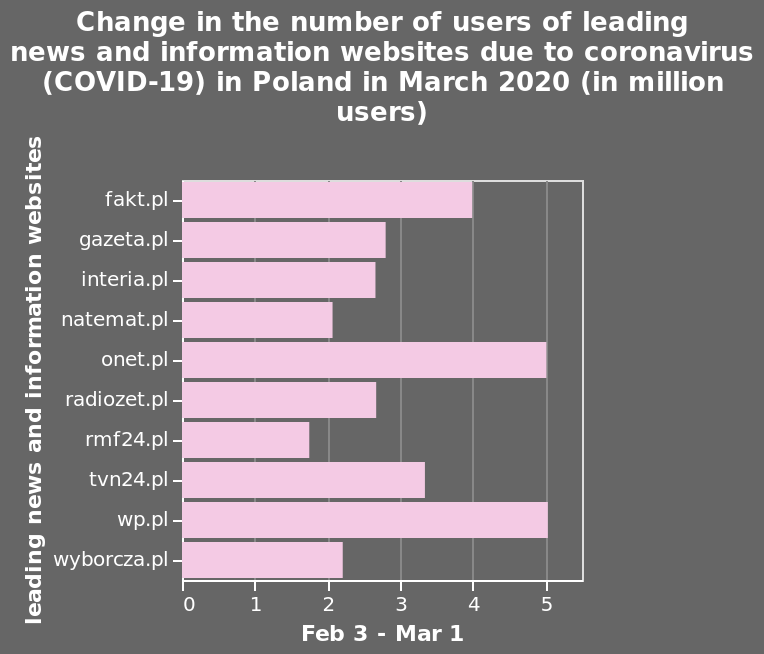<image>
Which two news sites experienced the highest increase in the number of users?  Onet.pl and wp.pl both experienced the equal highest increase in the number of users. 